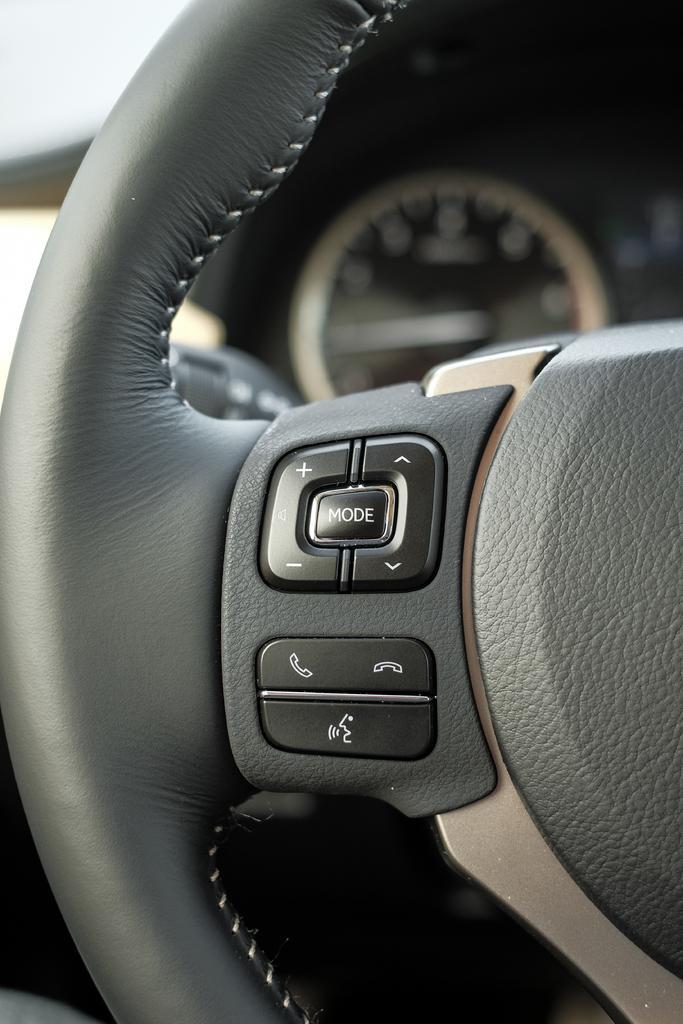In one or two sentences, can you explain what this image depicts? In this image we can see a steering with buttons. This is car gauge. 